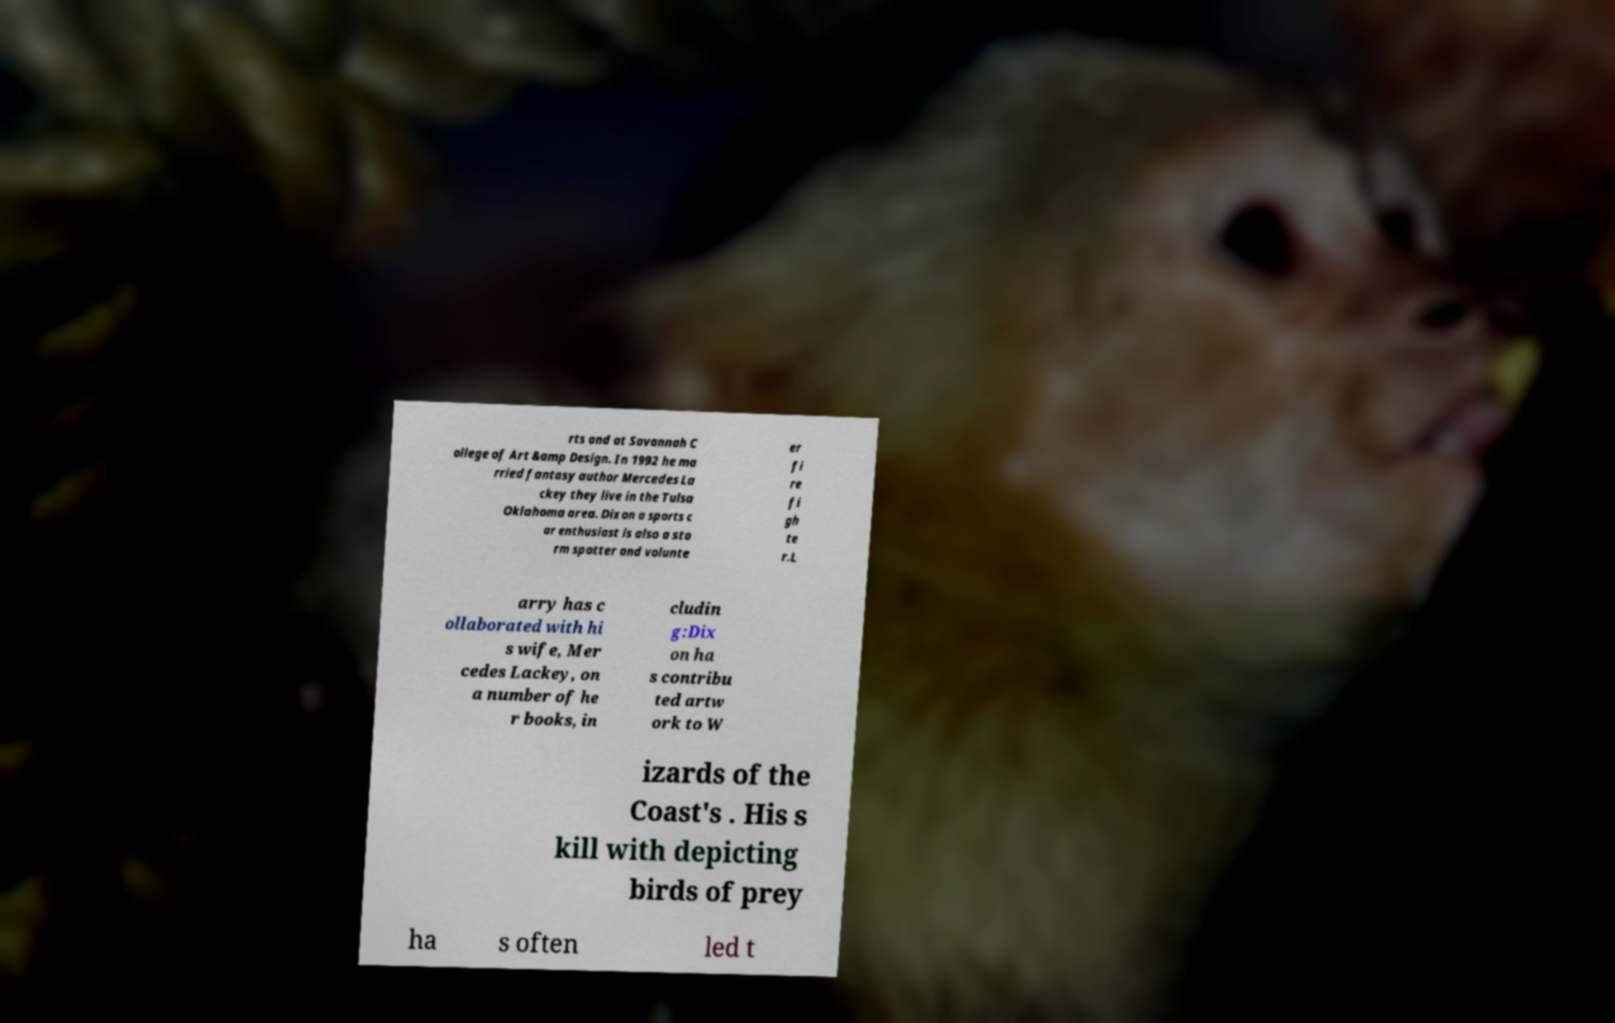Please read and relay the text visible in this image. What does it say? rts and at Savannah C ollege of Art &amp Design. In 1992 he ma rried fantasy author Mercedes La ckey they live in the Tulsa Oklahoma area. Dixon a sports c ar enthusiast is also a sto rm spotter and volunte er fi re fi gh te r.L arry has c ollaborated with hi s wife, Mer cedes Lackey, on a number of he r books, in cludin g:Dix on ha s contribu ted artw ork to W izards of the Coast's . His s kill with depicting birds of prey ha s often led t 